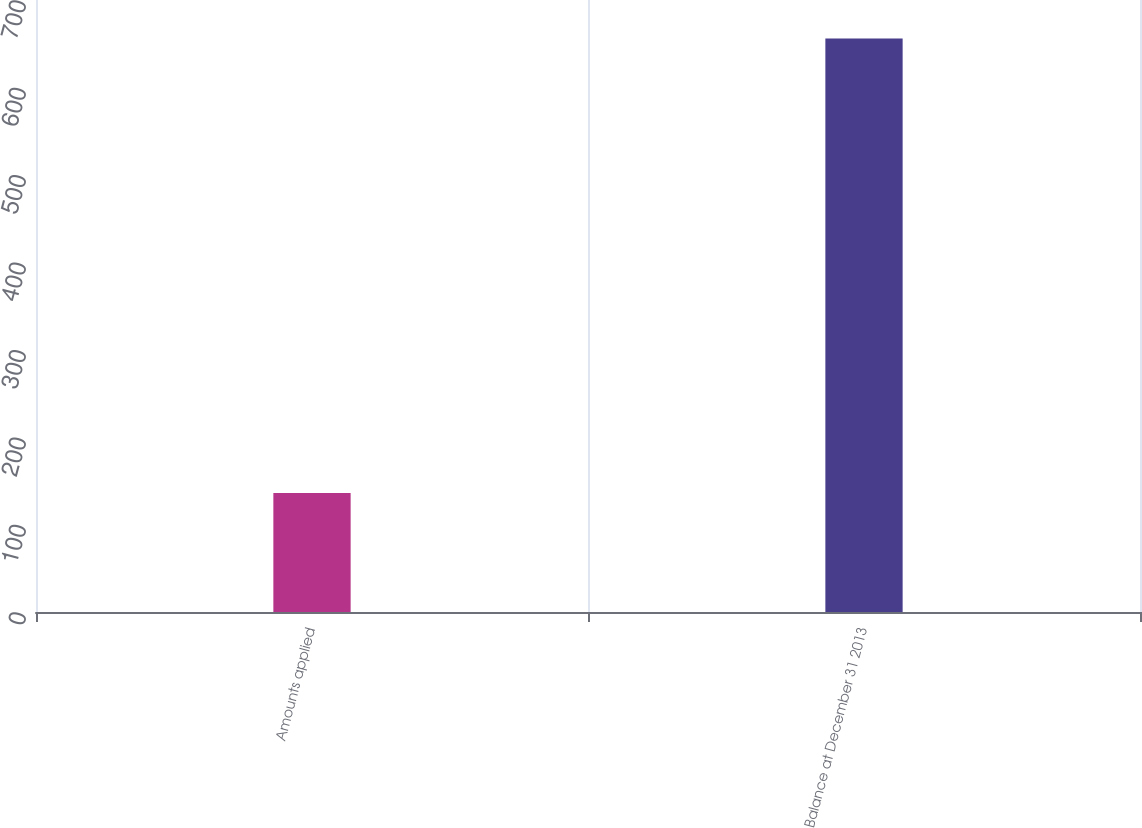Convert chart to OTSL. <chart><loc_0><loc_0><loc_500><loc_500><bar_chart><fcel>Amounts applied<fcel>Balance at December 31 2013<nl><fcel>136<fcel>656<nl></chart> 